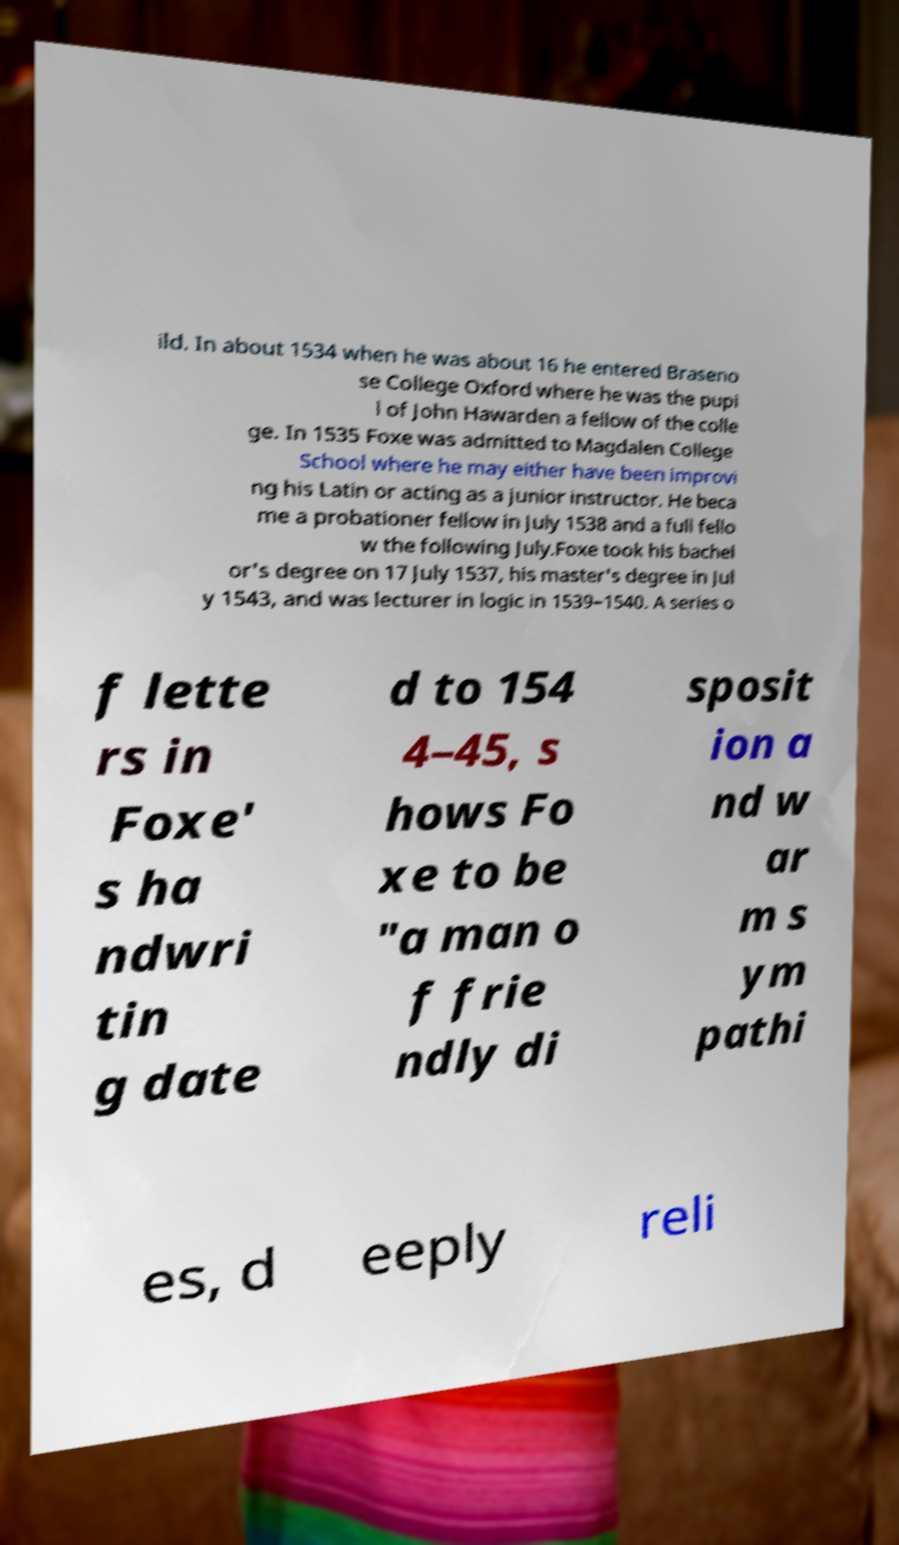Could you extract and type out the text from this image? ild. In about 1534 when he was about 16 he entered Braseno se College Oxford where he was the pupi l of John Hawarden a fellow of the colle ge. In 1535 Foxe was admitted to Magdalen College School where he may either have been improvi ng his Latin or acting as a junior instructor. He beca me a probationer fellow in July 1538 and a full fello w the following July.Foxe took his bachel or's degree on 17 July 1537, his master's degree in Jul y 1543, and was lecturer in logic in 1539–1540. A series o f lette rs in Foxe' s ha ndwri tin g date d to 154 4–45, s hows Fo xe to be "a man o f frie ndly di sposit ion a nd w ar m s ym pathi es, d eeply reli 